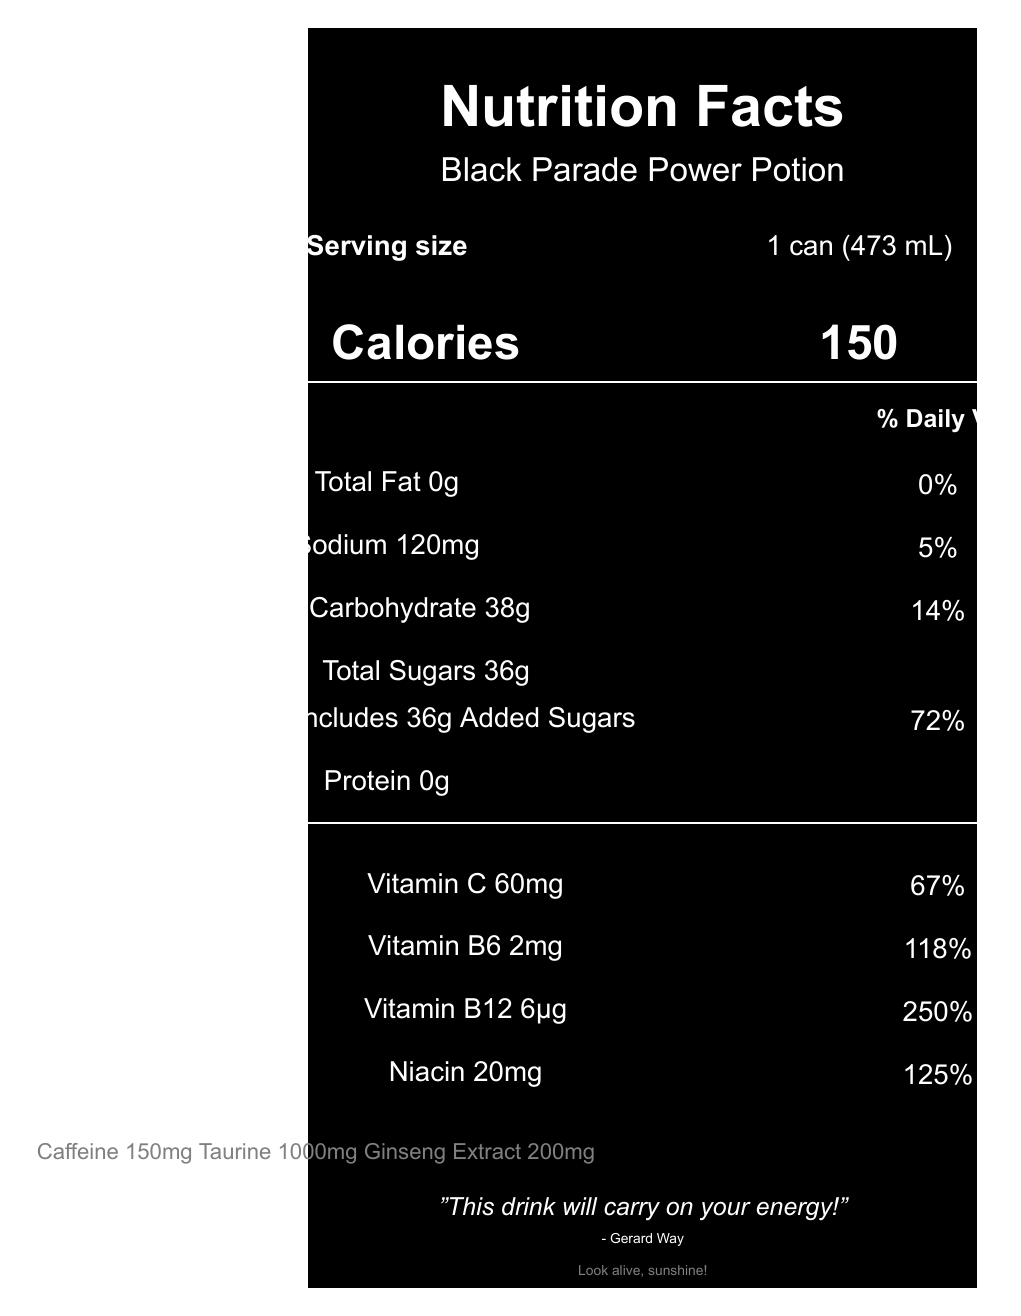what is the serving size for "Black Parade Power Potion"? The serving size is specified next to the label "Serving size" on the document.
Answer: 1 can (473 mL) how many calories are there per serving? The calorie count is displayed prominently beneath the title "Calories".
Answer: 150 calories what is the amount of sodium in a single serving? The sodium content is listed as "Sodium 120mg" under the nutrients section.
Answer: 120mg how much caffeine is in the "Black Parade Power Potion"? The caffeine content is mentioned at the bottom of the document with the additional info.
Answer: 150mg what is the percentage of daily value for Vitamin B12? The daily value for Vitamin B12 is listed as "250%" under the vitamins and minerals section.
Answer: 250% The total amount of sugars in the drink includes added sugars. (True/False) The document states "Includes 36g Added Sugars" under the total sugars section.
Answer: True What flavor profile does the "Black Parade Power Potion" have? The flavor profile is mentioned in the MCR-themed elements section.
Answer: Black Cherry and Licorice How much niacin is in the drink? The niacin content is listed as "Niacin 20mg" under the vitamins and minerals section.
Answer: 20mg What is the total carbohydrate content in "Black Parade Power Potion"? A. 25g B. 38g C. 45g D. 20g The total carbohydrate content is listed as "Total Carbohydrate 38g" under the nutrients section.
Answer: B. 38g What can design does the "Black Parade Power Potion" feature? A. Matte black with silver 'The Black Parade' skeleton artwork B. Glossy red with My Chemical Romance logo C. Metallic blue with Gerard Way's artwork The can design is described in the MCR-themed elements section.
Answer: A. Matte black with silver 'The Black Parade' skeleton artwork Is there any protein in "Black Parade Power Potion"? The protein amount is listed as "Protein 0g" under the nutrients section.
Answer: No What hidden message can be found on the can of "Black Parade Power Potion"? The hidden message is mentioned in the MCR-themed elements section.
Answer: Look alive, sunshine! Describe the main idea of the document. The document provides a comprehensive overview of the nutritional content and special My Chemical Romance-themed elements of the "Black Parade Power Potion" energy drink.
Answer: The document is a detailed Nutrition Facts label for a special edition My Chemical Romance-themed energy drink called "Black Parade Power Potion". It includes nutritional information such as serving size, calories, and vitamin content, as well as special design and theme elements related to My Chemical Romance. Who manufactured the "Black Parade Power Potion"? The document doesn't provide any details about the manufacturer.
Answer: Not enough information 